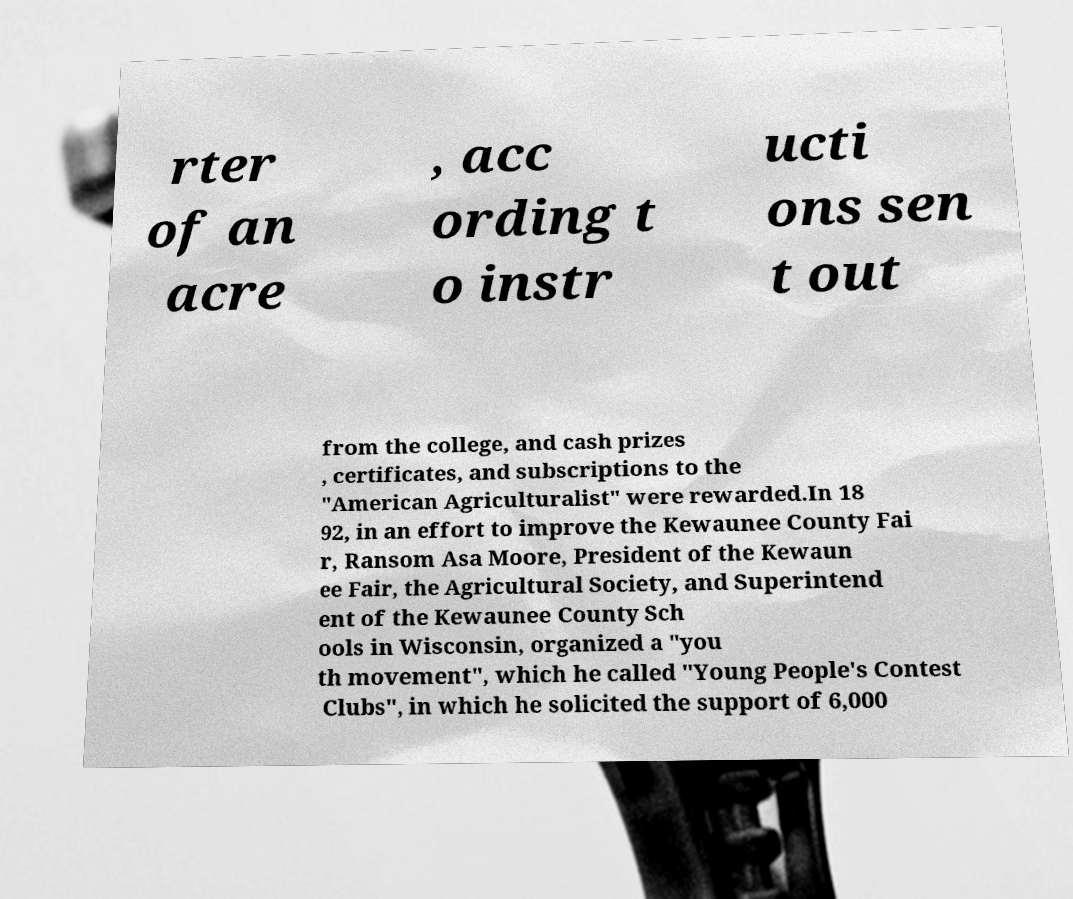Could you extract and type out the text from this image? rter of an acre , acc ording t o instr ucti ons sen t out from the college, and cash prizes , certificates, and subscriptions to the "American Agriculturalist" were rewarded.In 18 92, in an effort to improve the Kewaunee County Fai r, Ransom Asa Moore, President of the Kewaun ee Fair, the Agricultural Society, and Superintend ent of the Kewaunee County Sch ools in Wisconsin, organized a "you th movement", which he called "Young People's Contest Clubs", in which he solicited the support of 6,000 